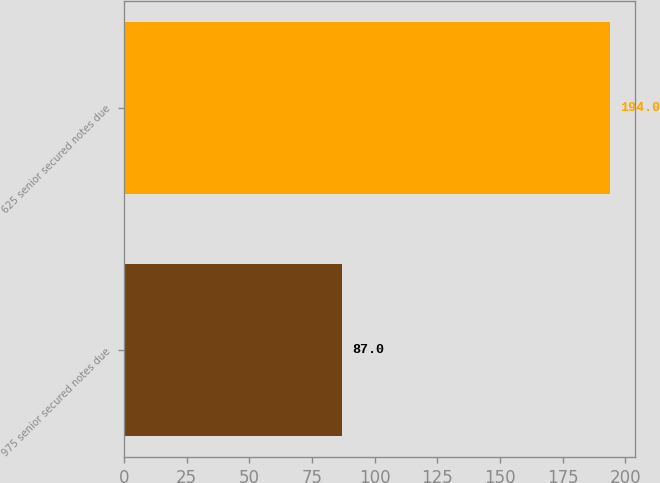Convert chart. <chart><loc_0><loc_0><loc_500><loc_500><bar_chart><fcel>975 senior secured notes due<fcel>625 senior secured notes due<nl><fcel>87<fcel>194<nl></chart> 